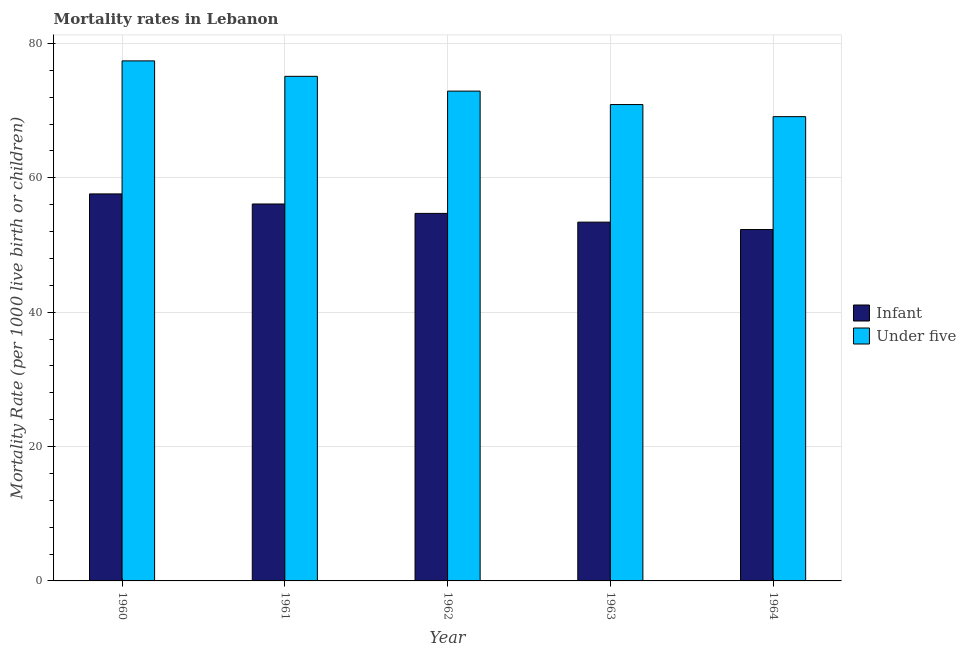How many different coloured bars are there?
Give a very brief answer. 2. How many groups of bars are there?
Your answer should be compact. 5. How many bars are there on the 3rd tick from the left?
Keep it short and to the point. 2. In how many cases, is the number of bars for a given year not equal to the number of legend labels?
Your response must be concise. 0. What is the under-5 mortality rate in 1960?
Your answer should be very brief. 77.4. Across all years, what is the maximum under-5 mortality rate?
Make the answer very short. 77.4. Across all years, what is the minimum infant mortality rate?
Your answer should be very brief. 52.3. In which year was the infant mortality rate maximum?
Make the answer very short. 1960. In which year was the infant mortality rate minimum?
Your response must be concise. 1964. What is the total under-5 mortality rate in the graph?
Offer a very short reply. 365.4. What is the difference between the under-5 mortality rate in 1961 and that in 1963?
Make the answer very short. 4.2. What is the difference between the infant mortality rate in 1963 and the under-5 mortality rate in 1961?
Give a very brief answer. -2.7. What is the average under-5 mortality rate per year?
Offer a terse response. 73.08. In the year 1964, what is the difference between the under-5 mortality rate and infant mortality rate?
Offer a terse response. 0. In how many years, is the under-5 mortality rate greater than 36?
Make the answer very short. 5. What is the ratio of the under-5 mortality rate in 1960 to that in 1964?
Give a very brief answer. 1.12. Is the infant mortality rate in 1961 less than that in 1964?
Your answer should be very brief. No. Is the difference between the under-5 mortality rate in 1963 and 1964 greater than the difference between the infant mortality rate in 1963 and 1964?
Offer a very short reply. No. What is the difference between the highest and the second highest under-5 mortality rate?
Provide a short and direct response. 2.3. What is the difference between the highest and the lowest under-5 mortality rate?
Make the answer very short. 8.3. Is the sum of the under-5 mortality rate in 1962 and 1964 greater than the maximum infant mortality rate across all years?
Provide a short and direct response. Yes. What does the 2nd bar from the left in 1962 represents?
Offer a terse response. Under five. What does the 1st bar from the right in 1964 represents?
Offer a terse response. Under five. How many bars are there?
Your answer should be compact. 10. Are all the bars in the graph horizontal?
Provide a succinct answer. No. Does the graph contain any zero values?
Ensure brevity in your answer.  No. Does the graph contain grids?
Provide a short and direct response. Yes. Where does the legend appear in the graph?
Give a very brief answer. Center right. How many legend labels are there?
Ensure brevity in your answer.  2. How are the legend labels stacked?
Your answer should be compact. Vertical. What is the title of the graph?
Give a very brief answer. Mortality rates in Lebanon. What is the label or title of the Y-axis?
Give a very brief answer. Mortality Rate (per 1000 live birth or children). What is the Mortality Rate (per 1000 live birth or children) in Infant in 1960?
Provide a short and direct response. 57.6. What is the Mortality Rate (per 1000 live birth or children) in Under five in 1960?
Provide a short and direct response. 77.4. What is the Mortality Rate (per 1000 live birth or children) of Infant in 1961?
Ensure brevity in your answer.  56.1. What is the Mortality Rate (per 1000 live birth or children) of Under five in 1961?
Give a very brief answer. 75.1. What is the Mortality Rate (per 1000 live birth or children) in Infant in 1962?
Your answer should be compact. 54.7. What is the Mortality Rate (per 1000 live birth or children) in Under five in 1962?
Give a very brief answer. 72.9. What is the Mortality Rate (per 1000 live birth or children) of Infant in 1963?
Give a very brief answer. 53.4. What is the Mortality Rate (per 1000 live birth or children) in Under five in 1963?
Provide a short and direct response. 70.9. What is the Mortality Rate (per 1000 live birth or children) of Infant in 1964?
Make the answer very short. 52.3. What is the Mortality Rate (per 1000 live birth or children) in Under five in 1964?
Your response must be concise. 69.1. Across all years, what is the maximum Mortality Rate (per 1000 live birth or children) in Infant?
Your answer should be compact. 57.6. Across all years, what is the maximum Mortality Rate (per 1000 live birth or children) of Under five?
Provide a short and direct response. 77.4. Across all years, what is the minimum Mortality Rate (per 1000 live birth or children) of Infant?
Your response must be concise. 52.3. Across all years, what is the minimum Mortality Rate (per 1000 live birth or children) of Under five?
Ensure brevity in your answer.  69.1. What is the total Mortality Rate (per 1000 live birth or children) of Infant in the graph?
Your answer should be very brief. 274.1. What is the total Mortality Rate (per 1000 live birth or children) in Under five in the graph?
Your answer should be very brief. 365.4. What is the difference between the Mortality Rate (per 1000 live birth or children) of Infant in 1960 and that in 1961?
Your response must be concise. 1.5. What is the difference between the Mortality Rate (per 1000 live birth or children) of Under five in 1960 and that in 1961?
Ensure brevity in your answer.  2.3. What is the difference between the Mortality Rate (per 1000 live birth or children) of Infant in 1960 and that in 1962?
Your response must be concise. 2.9. What is the difference between the Mortality Rate (per 1000 live birth or children) of Under five in 1960 and that in 1962?
Provide a succinct answer. 4.5. What is the difference between the Mortality Rate (per 1000 live birth or children) in Infant in 1960 and that in 1963?
Provide a succinct answer. 4.2. What is the difference between the Mortality Rate (per 1000 live birth or children) of Under five in 1960 and that in 1963?
Provide a succinct answer. 6.5. What is the difference between the Mortality Rate (per 1000 live birth or children) of Infant in 1960 and that in 1964?
Keep it short and to the point. 5.3. What is the difference between the Mortality Rate (per 1000 live birth or children) in Under five in 1960 and that in 1964?
Offer a very short reply. 8.3. What is the difference between the Mortality Rate (per 1000 live birth or children) in Infant in 1961 and that in 1963?
Make the answer very short. 2.7. What is the difference between the Mortality Rate (per 1000 live birth or children) of Infant in 1961 and that in 1964?
Your answer should be very brief. 3.8. What is the difference between the Mortality Rate (per 1000 live birth or children) in Under five in 1961 and that in 1964?
Provide a short and direct response. 6. What is the difference between the Mortality Rate (per 1000 live birth or children) of Infant in 1962 and that in 1963?
Offer a terse response. 1.3. What is the difference between the Mortality Rate (per 1000 live birth or children) in Under five in 1962 and that in 1963?
Offer a very short reply. 2. What is the difference between the Mortality Rate (per 1000 live birth or children) in Infant in 1962 and that in 1964?
Your answer should be compact. 2.4. What is the difference between the Mortality Rate (per 1000 live birth or children) in Infant in 1963 and that in 1964?
Provide a succinct answer. 1.1. What is the difference between the Mortality Rate (per 1000 live birth or children) of Under five in 1963 and that in 1964?
Ensure brevity in your answer.  1.8. What is the difference between the Mortality Rate (per 1000 live birth or children) of Infant in 1960 and the Mortality Rate (per 1000 live birth or children) of Under five in 1961?
Your answer should be very brief. -17.5. What is the difference between the Mortality Rate (per 1000 live birth or children) of Infant in 1960 and the Mortality Rate (per 1000 live birth or children) of Under five in 1962?
Your answer should be very brief. -15.3. What is the difference between the Mortality Rate (per 1000 live birth or children) in Infant in 1960 and the Mortality Rate (per 1000 live birth or children) in Under five in 1963?
Provide a short and direct response. -13.3. What is the difference between the Mortality Rate (per 1000 live birth or children) in Infant in 1961 and the Mortality Rate (per 1000 live birth or children) in Under five in 1962?
Offer a terse response. -16.8. What is the difference between the Mortality Rate (per 1000 live birth or children) in Infant in 1961 and the Mortality Rate (per 1000 live birth or children) in Under five in 1963?
Offer a terse response. -14.8. What is the difference between the Mortality Rate (per 1000 live birth or children) in Infant in 1962 and the Mortality Rate (per 1000 live birth or children) in Under five in 1963?
Provide a succinct answer. -16.2. What is the difference between the Mortality Rate (per 1000 live birth or children) in Infant in 1962 and the Mortality Rate (per 1000 live birth or children) in Under five in 1964?
Make the answer very short. -14.4. What is the difference between the Mortality Rate (per 1000 live birth or children) of Infant in 1963 and the Mortality Rate (per 1000 live birth or children) of Under five in 1964?
Your response must be concise. -15.7. What is the average Mortality Rate (per 1000 live birth or children) in Infant per year?
Keep it short and to the point. 54.82. What is the average Mortality Rate (per 1000 live birth or children) in Under five per year?
Your answer should be compact. 73.08. In the year 1960, what is the difference between the Mortality Rate (per 1000 live birth or children) of Infant and Mortality Rate (per 1000 live birth or children) of Under five?
Your answer should be compact. -19.8. In the year 1962, what is the difference between the Mortality Rate (per 1000 live birth or children) of Infant and Mortality Rate (per 1000 live birth or children) of Under five?
Your response must be concise. -18.2. In the year 1963, what is the difference between the Mortality Rate (per 1000 live birth or children) of Infant and Mortality Rate (per 1000 live birth or children) of Under five?
Provide a succinct answer. -17.5. In the year 1964, what is the difference between the Mortality Rate (per 1000 live birth or children) of Infant and Mortality Rate (per 1000 live birth or children) of Under five?
Offer a very short reply. -16.8. What is the ratio of the Mortality Rate (per 1000 live birth or children) in Infant in 1960 to that in 1961?
Ensure brevity in your answer.  1.03. What is the ratio of the Mortality Rate (per 1000 live birth or children) in Under five in 1960 to that in 1961?
Ensure brevity in your answer.  1.03. What is the ratio of the Mortality Rate (per 1000 live birth or children) of Infant in 1960 to that in 1962?
Make the answer very short. 1.05. What is the ratio of the Mortality Rate (per 1000 live birth or children) in Under five in 1960 to that in 1962?
Provide a succinct answer. 1.06. What is the ratio of the Mortality Rate (per 1000 live birth or children) of Infant in 1960 to that in 1963?
Ensure brevity in your answer.  1.08. What is the ratio of the Mortality Rate (per 1000 live birth or children) of Under five in 1960 to that in 1963?
Keep it short and to the point. 1.09. What is the ratio of the Mortality Rate (per 1000 live birth or children) of Infant in 1960 to that in 1964?
Your answer should be very brief. 1.1. What is the ratio of the Mortality Rate (per 1000 live birth or children) in Under five in 1960 to that in 1964?
Ensure brevity in your answer.  1.12. What is the ratio of the Mortality Rate (per 1000 live birth or children) in Infant in 1961 to that in 1962?
Your answer should be compact. 1.03. What is the ratio of the Mortality Rate (per 1000 live birth or children) of Under five in 1961 to that in 1962?
Keep it short and to the point. 1.03. What is the ratio of the Mortality Rate (per 1000 live birth or children) in Infant in 1961 to that in 1963?
Provide a succinct answer. 1.05. What is the ratio of the Mortality Rate (per 1000 live birth or children) in Under five in 1961 to that in 1963?
Keep it short and to the point. 1.06. What is the ratio of the Mortality Rate (per 1000 live birth or children) of Infant in 1961 to that in 1964?
Your response must be concise. 1.07. What is the ratio of the Mortality Rate (per 1000 live birth or children) of Under five in 1961 to that in 1964?
Your answer should be very brief. 1.09. What is the ratio of the Mortality Rate (per 1000 live birth or children) of Infant in 1962 to that in 1963?
Give a very brief answer. 1.02. What is the ratio of the Mortality Rate (per 1000 live birth or children) in Under five in 1962 to that in 1963?
Give a very brief answer. 1.03. What is the ratio of the Mortality Rate (per 1000 live birth or children) of Infant in 1962 to that in 1964?
Ensure brevity in your answer.  1.05. What is the ratio of the Mortality Rate (per 1000 live birth or children) in Under five in 1962 to that in 1964?
Ensure brevity in your answer.  1.05. What is the ratio of the Mortality Rate (per 1000 live birth or children) in Infant in 1963 to that in 1964?
Keep it short and to the point. 1.02. What is the difference between the highest and the second highest Mortality Rate (per 1000 live birth or children) in Infant?
Give a very brief answer. 1.5. What is the difference between the highest and the second highest Mortality Rate (per 1000 live birth or children) in Under five?
Ensure brevity in your answer.  2.3. 